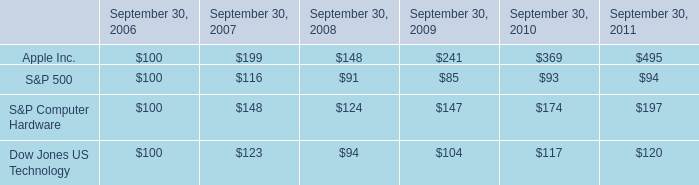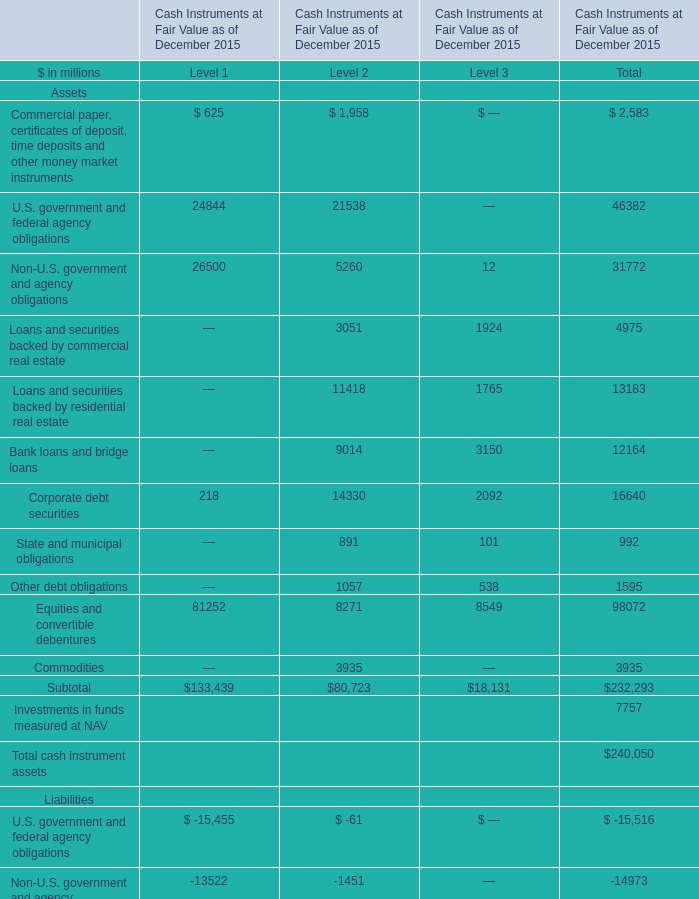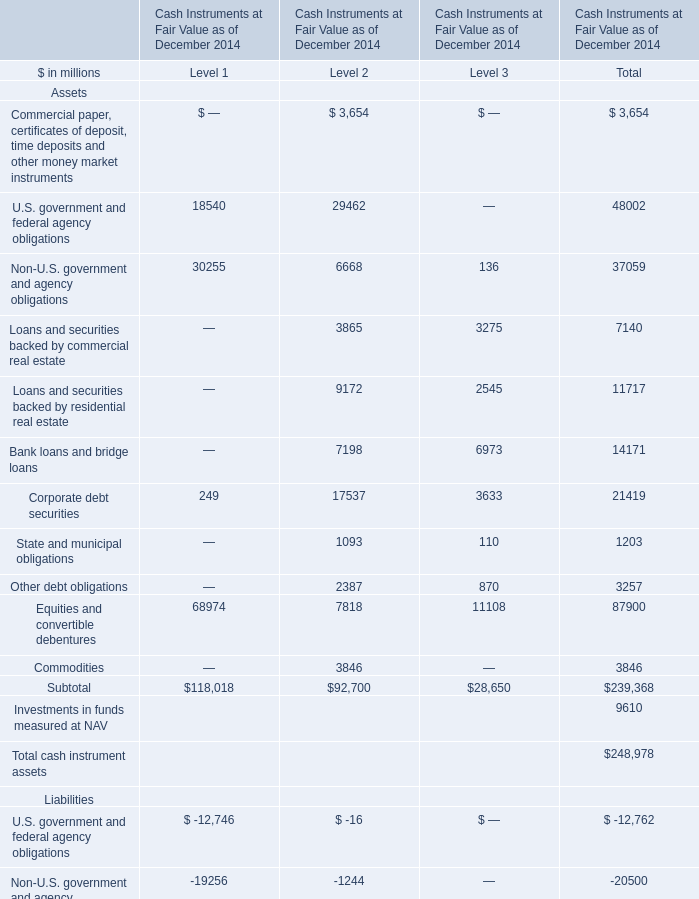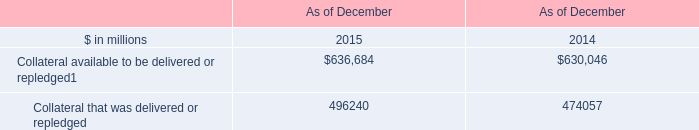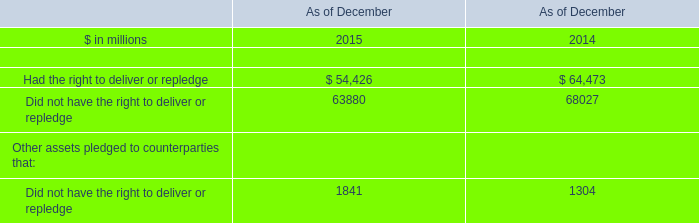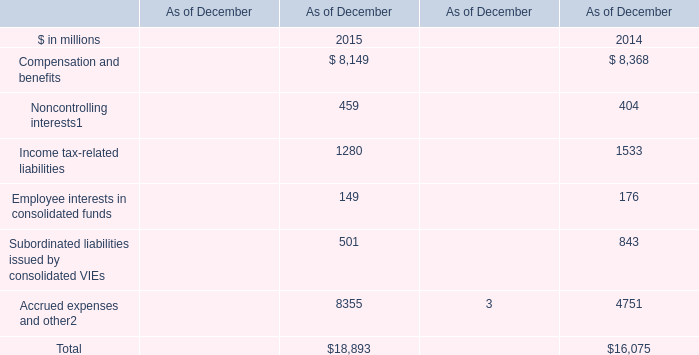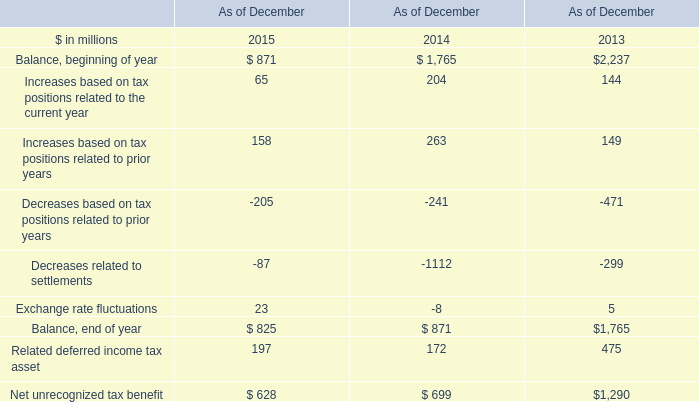What is the amount all Commercial paper, certificates of deposit, time deposits and other money market instruments that are in the range of 1 and 100000 in 2015? (in million) 
Computations: (625 + 1958)
Answer: 2583.0. 